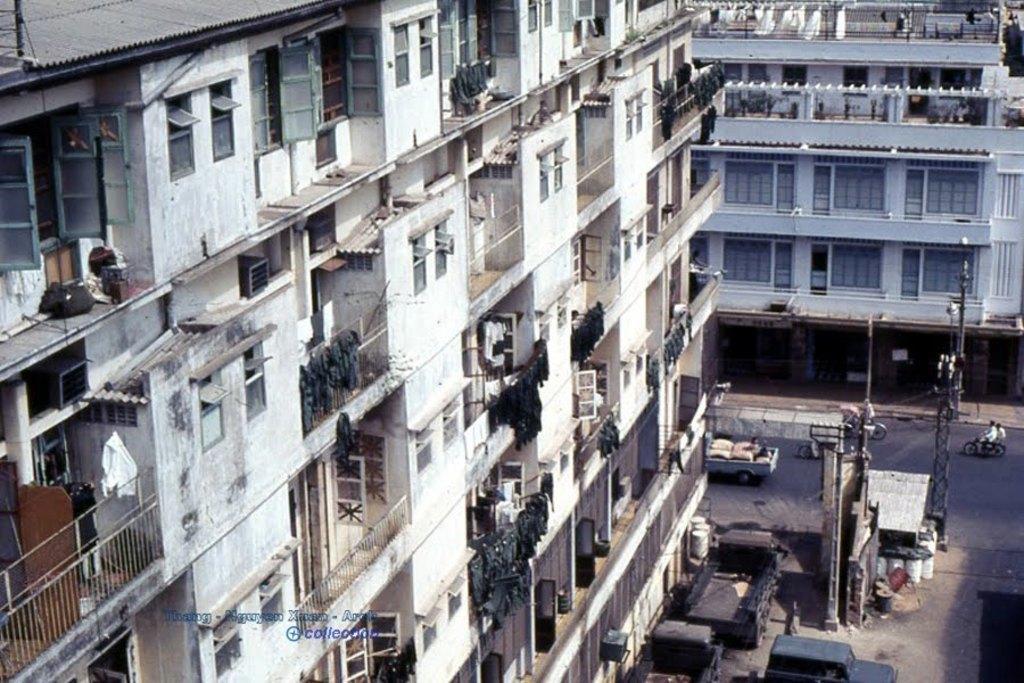Describe this image in one or two sentences. In the picture we can see a building with railings, windows, and near to the building we can see a truck on the path and some persons are riding motorcycle on the road and beside we can see another building with windows. 